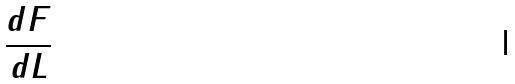<formula> <loc_0><loc_0><loc_500><loc_500>\frac { d F } { d L }</formula> 